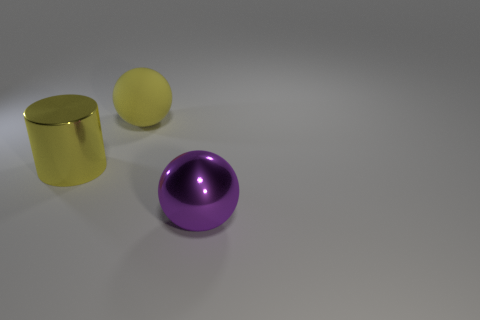Does the large purple thing have the same material as the large ball behind the large yellow cylinder? no 